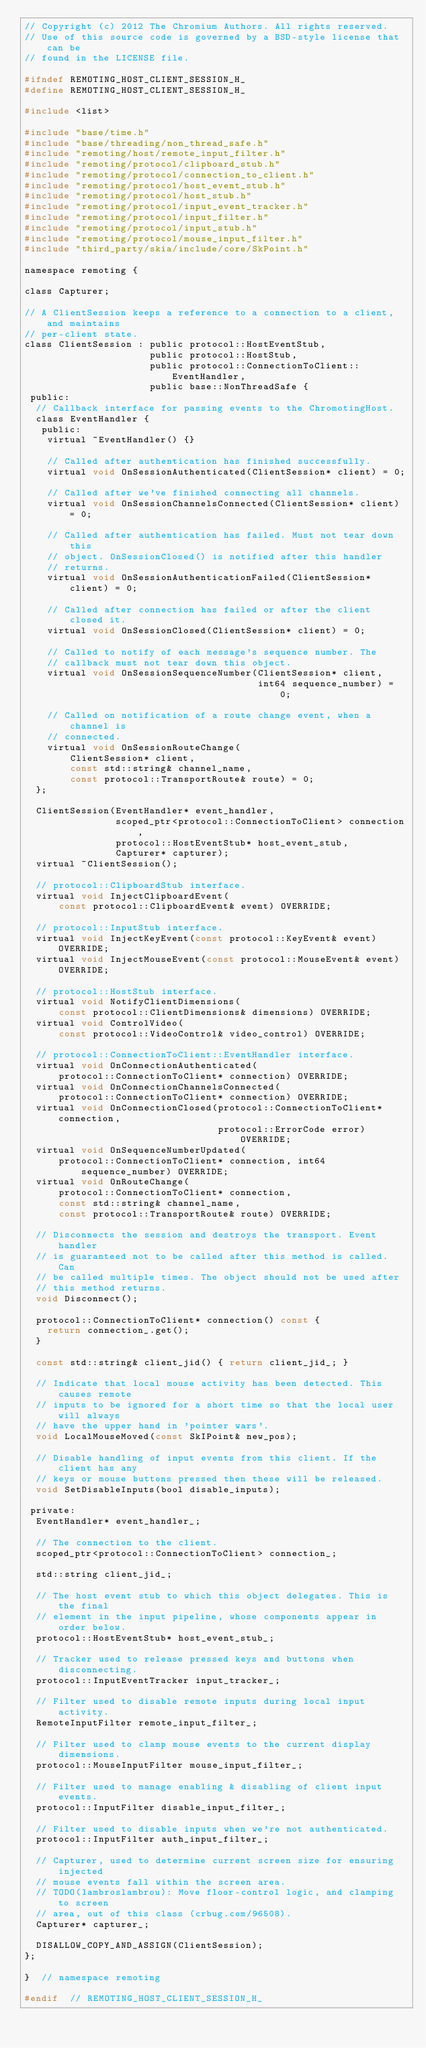Convert code to text. <code><loc_0><loc_0><loc_500><loc_500><_C_>// Copyright (c) 2012 The Chromium Authors. All rights reserved.
// Use of this source code is governed by a BSD-style license that can be
// found in the LICENSE file.

#ifndef REMOTING_HOST_CLIENT_SESSION_H_
#define REMOTING_HOST_CLIENT_SESSION_H_

#include <list>

#include "base/time.h"
#include "base/threading/non_thread_safe.h"
#include "remoting/host/remote_input_filter.h"
#include "remoting/protocol/clipboard_stub.h"
#include "remoting/protocol/connection_to_client.h"
#include "remoting/protocol/host_event_stub.h"
#include "remoting/protocol/host_stub.h"
#include "remoting/protocol/input_event_tracker.h"
#include "remoting/protocol/input_filter.h"
#include "remoting/protocol/input_stub.h"
#include "remoting/protocol/mouse_input_filter.h"
#include "third_party/skia/include/core/SkPoint.h"

namespace remoting {

class Capturer;

// A ClientSession keeps a reference to a connection to a client, and maintains
// per-client state.
class ClientSession : public protocol::HostEventStub,
                      public protocol::HostStub,
                      public protocol::ConnectionToClient::EventHandler,
                      public base::NonThreadSafe {
 public:
  // Callback interface for passing events to the ChromotingHost.
  class EventHandler {
   public:
    virtual ~EventHandler() {}

    // Called after authentication has finished successfully.
    virtual void OnSessionAuthenticated(ClientSession* client) = 0;

    // Called after we've finished connecting all channels.
    virtual void OnSessionChannelsConnected(ClientSession* client) = 0;

    // Called after authentication has failed. Must not tear down this
    // object. OnSessionClosed() is notified after this handler
    // returns.
    virtual void OnSessionAuthenticationFailed(ClientSession* client) = 0;

    // Called after connection has failed or after the client closed it.
    virtual void OnSessionClosed(ClientSession* client) = 0;

    // Called to notify of each message's sequence number. The
    // callback must not tear down this object.
    virtual void OnSessionSequenceNumber(ClientSession* client,
                                         int64 sequence_number) = 0;

    // Called on notification of a route change event, when a channel is
    // connected.
    virtual void OnSessionRouteChange(
        ClientSession* client,
        const std::string& channel_name,
        const protocol::TransportRoute& route) = 0;
  };

  ClientSession(EventHandler* event_handler,
                scoped_ptr<protocol::ConnectionToClient> connection,
                protocol::HostEventStub* host_event_stub,
                Capturer* capturer);
  virtual ~ClientSession();

  // protocol::ClipboardStub interface.
  virtual void InjectClipboardEvent(
      const protocol::ClipboardEvent& event) OVERRIDE;

  // protocol::InputStub interface.
  virtual void InjectKeyEvent(const protocol::KeyEvent& event) OVERRIDE;
  virtual void InjectMouseEvent(const protocol::MouseEvent& event) OVERRIDE;

  // protocol::HostStub interface.
  virtual void NotifyClientDimensions(
      const protocol::ClientDimensions& dimensions) OVERRIDE;
  virtual void ControlVideo(
      const protocol::VideoControl& video_control) OVERRIDE;

  // protocol::ConnectionToClient::EventHandler interface.
  virtual void OnConnectionAuthenticated(
      protocol::ConnectionToClient* connection) OVERRIDE;
  virtual void OnConnectionChannelsConnected(
      protocol::ConnectionToClient* connection) OVERRIDE;
  virtual void OnConnectionClosed(protocol::ConnectionToClient* connection,
                                  protocol::ErrorCode error) OVERRIDE;
  virtual void OnSequenceNumberUpdated(
      protocol::ConnectionToClient* connection, int64 sequence_number) OVERRIDE;
  virtual void OnRouteChange(
      protocol::ConnectionToClient* connection,
      const std::string& channel_name,
      const protocol::TransportRoute& route) OVERRIDE;

  // Disconnects the session and destroys the transport. Event handler
  // is guaranteed not to be called after this method is called. Can
  // be called multiple times. The object should not be used after
  // this method returns.
  void Disconnect();

  protocol::ConnectionToClient* connection() const {
    return connection_.get();
  }

  const std::string& client_jid() { return client_jid_; }

  // Indicate that local mouse activity has been detected. This causes remote
  // inputs to be ignored for a short time so that the local user will always
  // have the upper hand in 'pointer wars'.
  void LocalMouseMoved(const SkIPoint& new_pos);

  // Disable handling of input events from this client. If the client has any
  // keys or mouse buttons pressed then these will be released.
  void SetDisableInputs(bool disable_inputs);

 private:
  EventHandler* event_handler_;

  // The connection to the client.
  scoped_ptr<protocol::ConnectionToClient> connection_;

  std::string client_jid_;

  // The host event stub to which this object delegates. This is the final
  // element in the input pipeline, whose components appear in order below.
  protocol::HostEventStub* host_event_stub_;

  // Tracker used to release pressed keys and buttons when disconnecting.
  protocol::InputEventTracker input_tracker_;

  // Filter used to disable remote inputs during local input activity.
  RemoteInputFilter remote_input_filter_;

  // Filter used to clamp mouse events to the current display dimensions.
  protocol::MouseInputFilter mouse_input_filter_;

  // Filter used to manage enabling & disabling of client input events.
  protocol::InputFilter disable_input_filter_;

  // Filter used to disable inputs when we're not authenticated.
  protocol::InputFilter auth_input_filter_;

  // Capturer, used to determine current screen size for ensuring injected
  // mouse events fall within the screen area.
  // TODO(lambroslambrou): Move floor-control logic, and clamping to screen
  // area, out of this class (crbug.com/96508).
  Capturer* capturer_;

  DISALLOW_COPY_AND_ASSIGN(ClientSession);
};

}  // namespace remoting

#endif  // REMOTING_HOST_CLIENT_SESSION_H_
</code> 